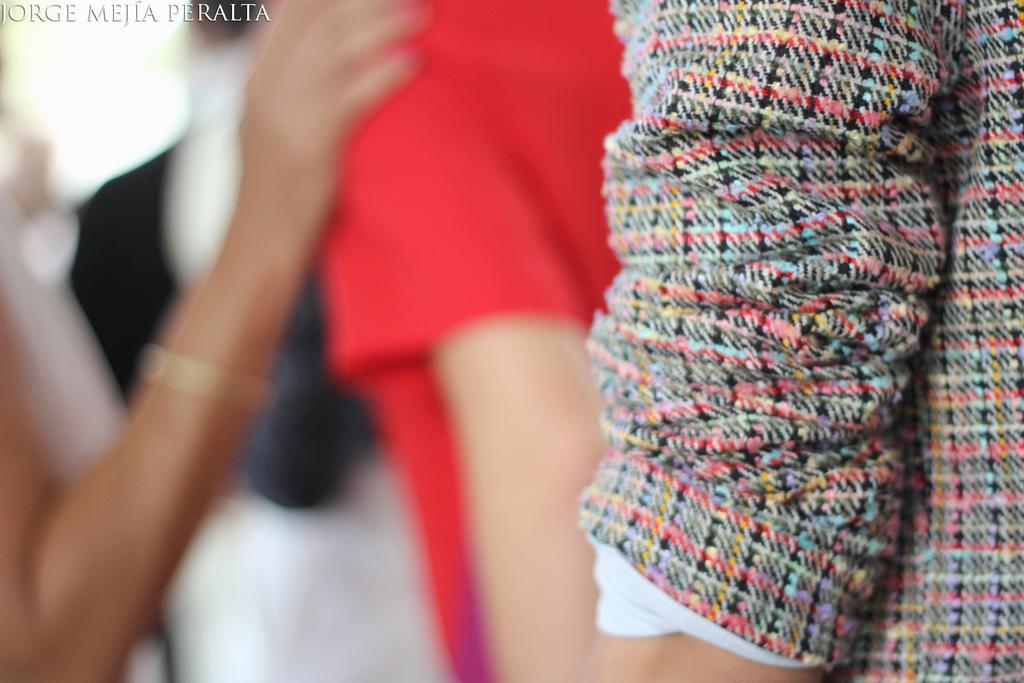What is the overall quality of the image? The image is blurred. Can you identify any subjects in the image? Yes, there are people visible in the image. Is there any additional information or branding present in the image? Yes, there is a watermark present in the image. What type of notebook is being used by the people in the image? There is no notebook visible in the image; it is blurred and only shows people. What kind of loss is being experienced by the people in the image? There is no indication of loss in the image; it only shows people and is blurred. 